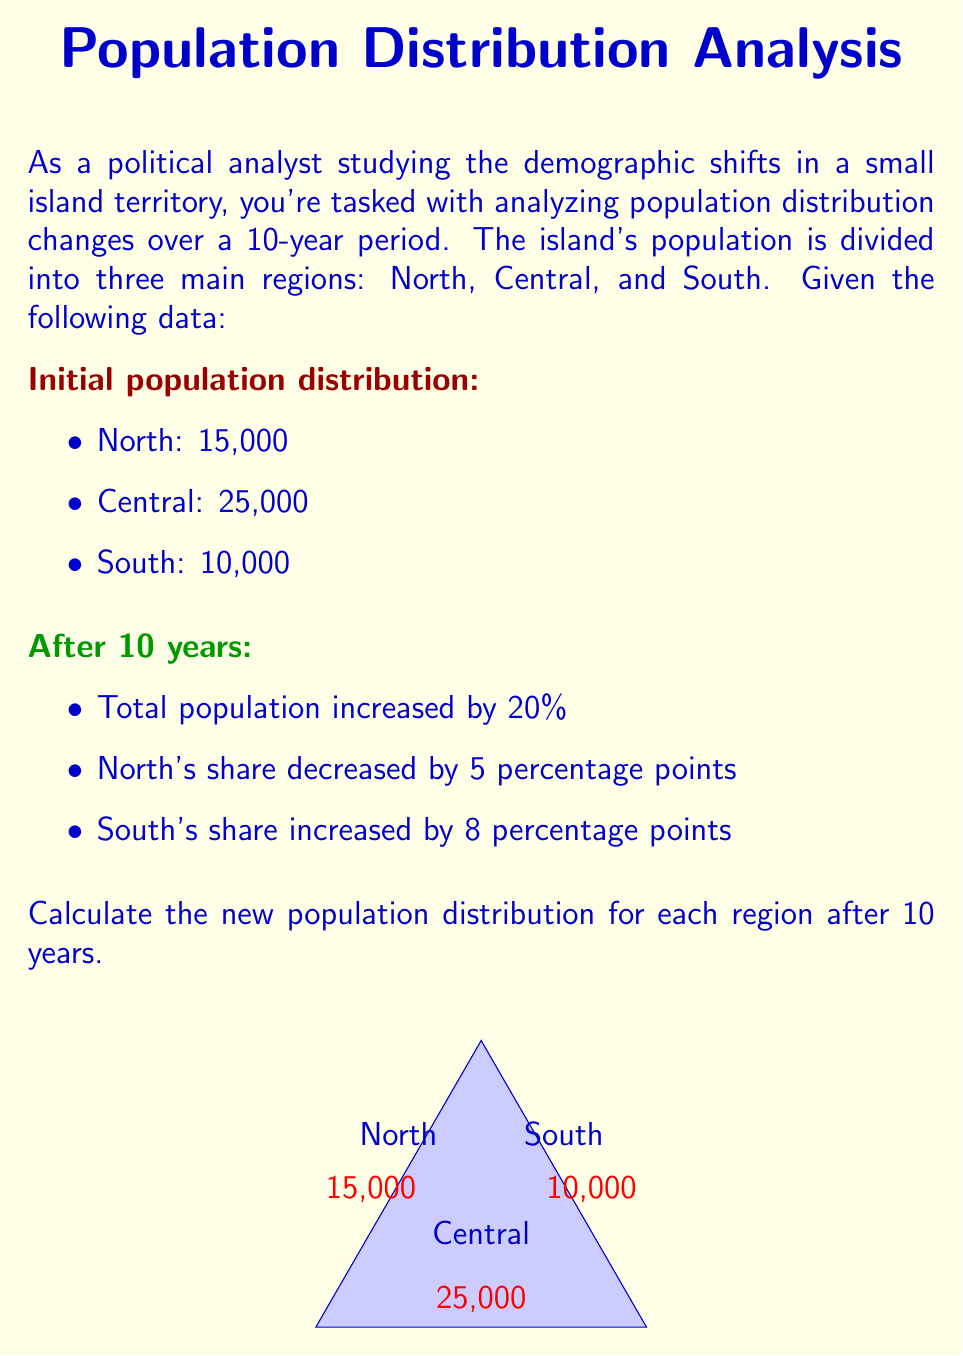Help me with this question. Let's approach this step-by-step:

1) First, calculate the total initial population:
   $15,000 + 25,000 + 10,000 = 50,000$

2) Calculate the new total population after 20% increase:
   $50,000 \times 1.20 = 60,000$

3) Calculate initial percentages for each region:
   North: $\frac{15,000}{50,000} \times 100\% = 30\%$
   Central: $\frac{25,000}{50,000} \times 100\% = 50\%$
   South: $\frac{10,000}{50,000} \times 100\% = 20\%$

4) Apply the percentage point changes:
   North: $30\% - 5\% = 25\%$
   South: $20\% + 8\% = 28\%$
   Central (by difference): $100\% - 25\% - 28\% = 47\%$

5) Calculate new populations:
   North: $60,000 \times 25\% = 15,000$
   Central: $60,000 \times 47\% = 28,200$
   South: $60,000 \times 28\% = 16,800$

6) Verify: $15,000 + 28,200 + 16,800 = 60,000$

Thus, the new population distribution after 10 years is:
North: 15,000
Central: 28,200
South: 16,800
Answer: North: 15,000; Central: 28,200; South: 16,800 